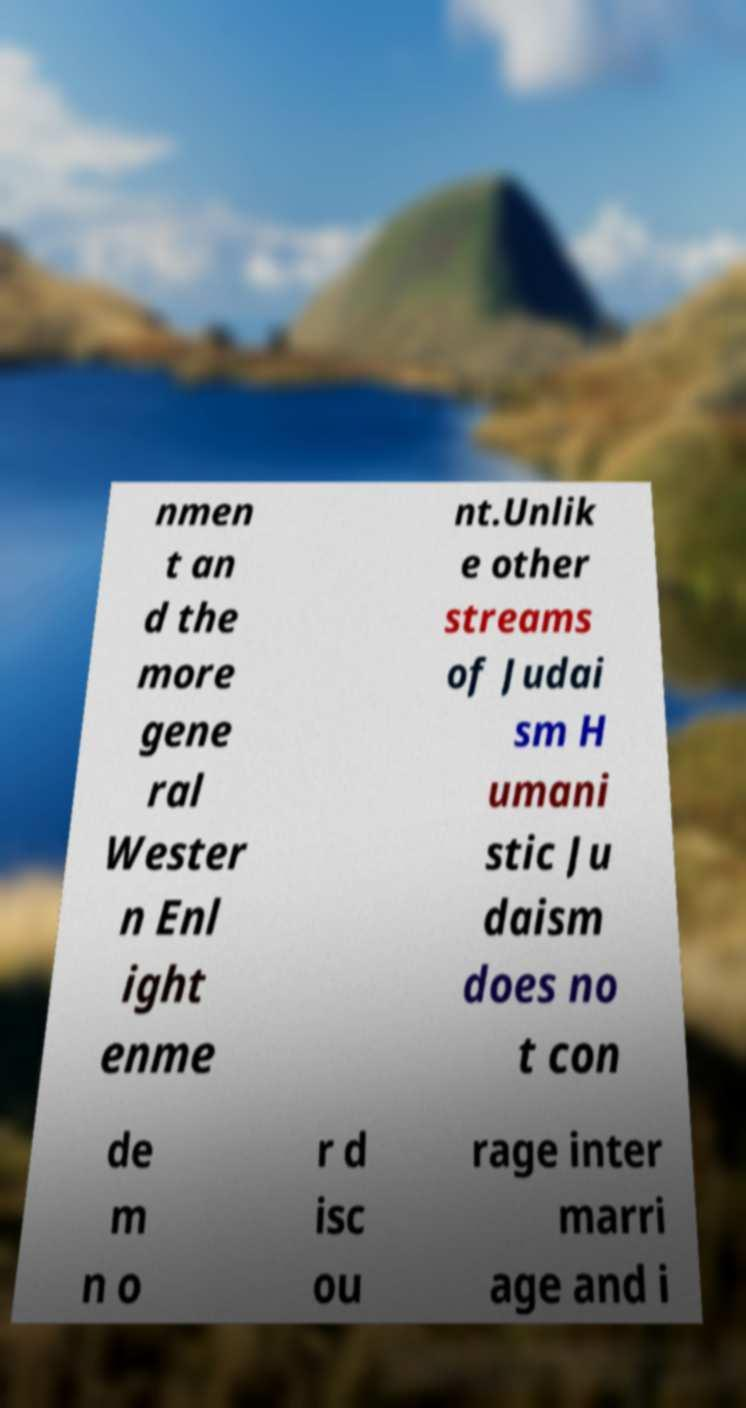Can you accurately transcribe the text from the provided image for me? nmen t an d the more gene ral Wester n Enl ight enme nt.Unlik e other streams of Judai sm H umani stic Ju daism does no t con de m n o r d isc ou rage inter marri age and i 